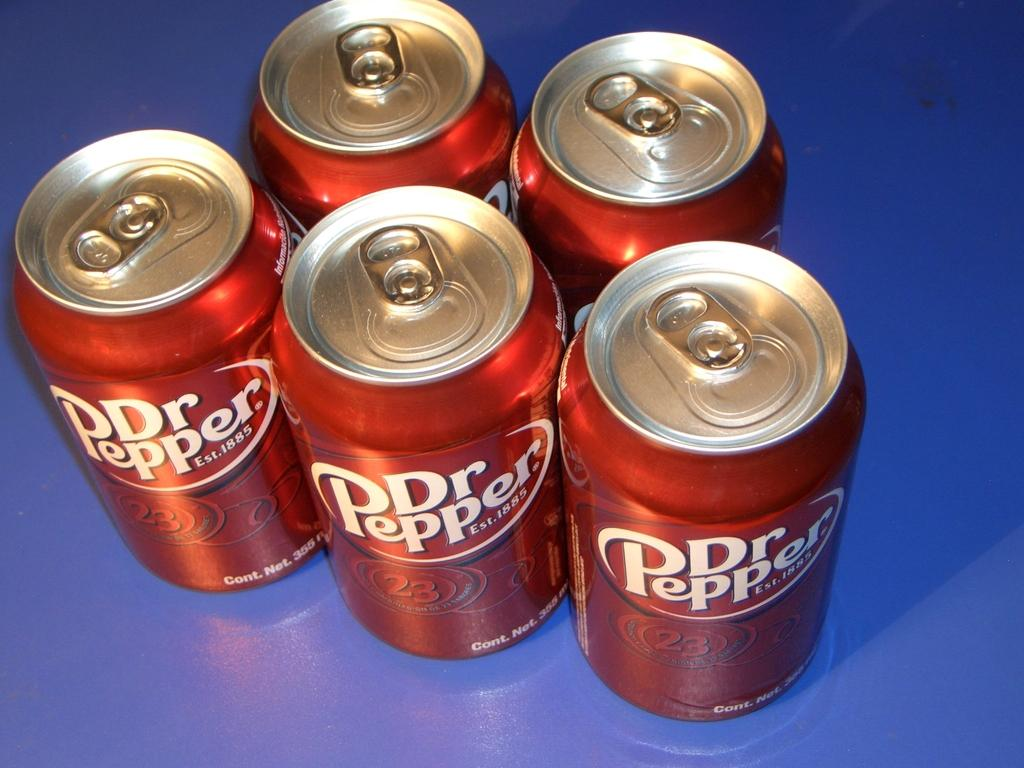<image>
Present a compact description of the photo's key features. Five cans of Dr. Pepper sit on a blue surface. 